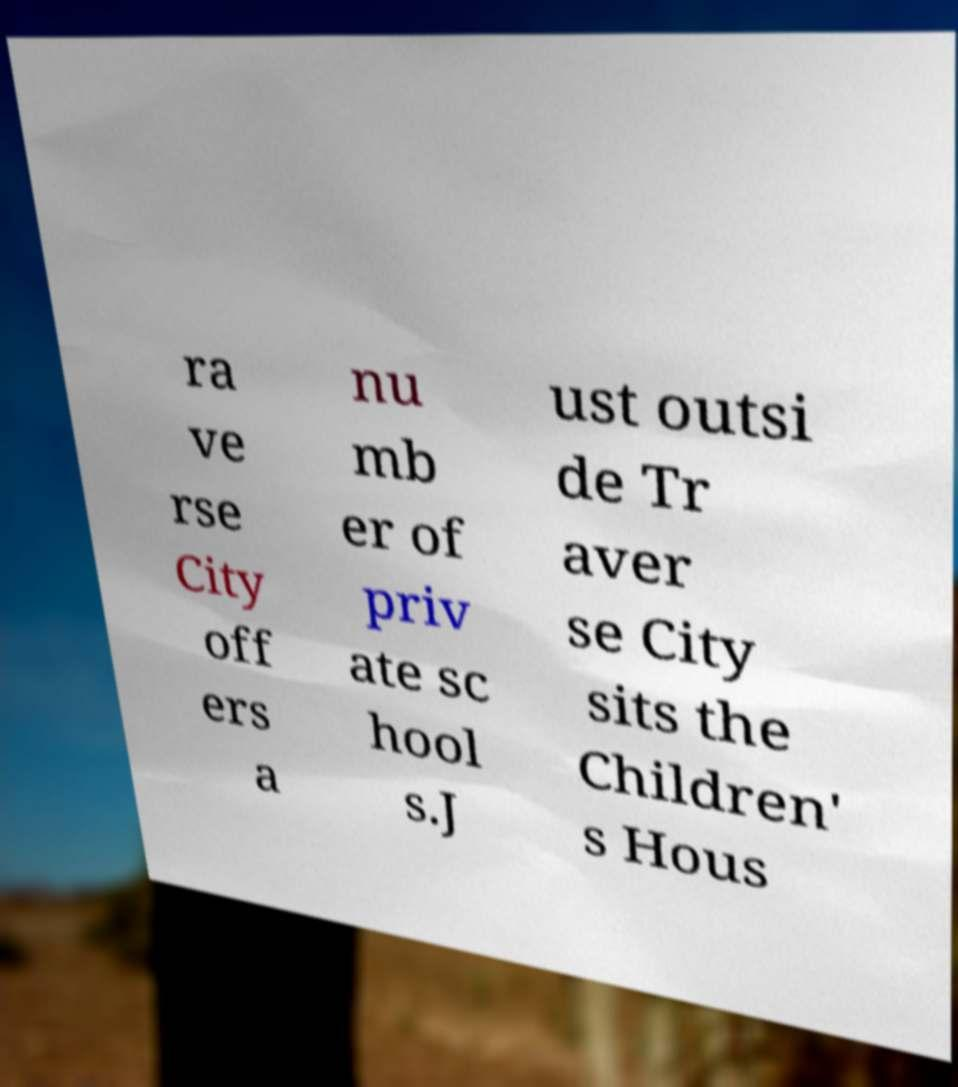Could you assist in decoding the text presented in this image and type it out clearly? ra ve rse City off ers a nu mb er of priv ate sc hool s.J ust outsi de Tr aver se City sits the Children' s Hous 